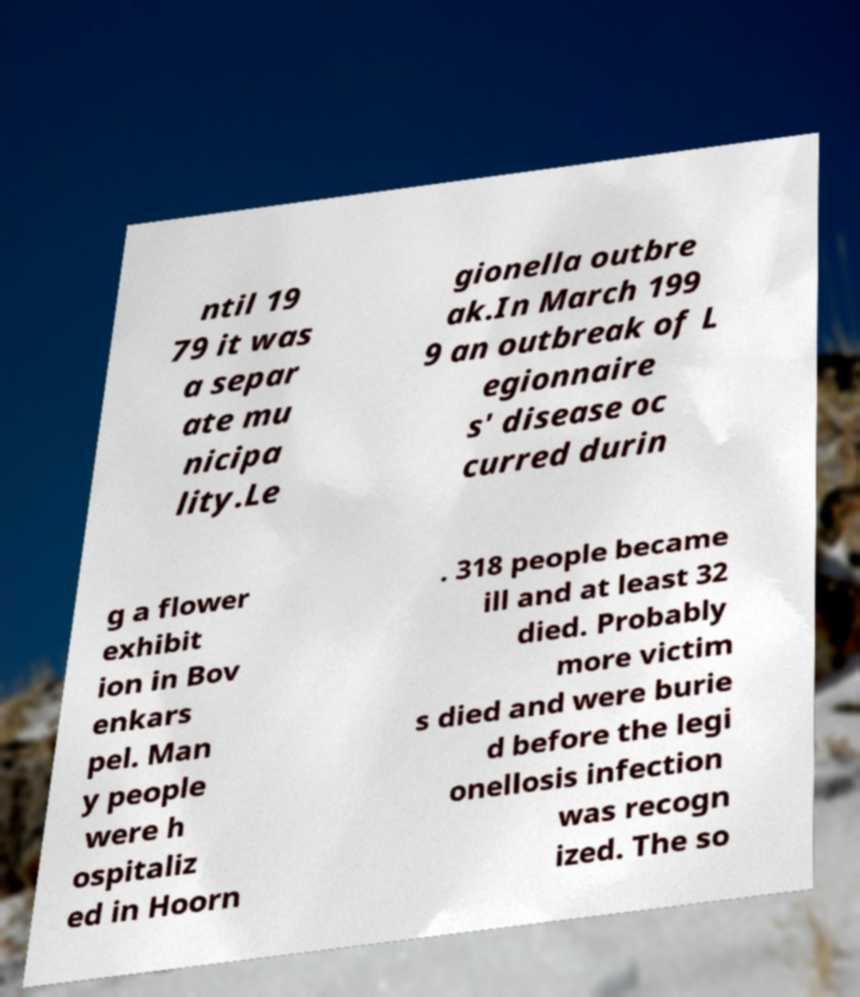Please read and relay the text visible in this image. What does it say? ntil 19 79 it was a separ ate mu nicipa lity.Le gionella outbre ak.In March 199 9 an outbreak of L egionnaire s' disease oc curred durin g a flower exhibit ion in Bov enkars pel. Man y people were h ospitaliz ed in Hoorn . 318 people became ill and at least 32 died. Probably more victim s died and were burie d before the legi onellosis infection was recogn ized. The so 